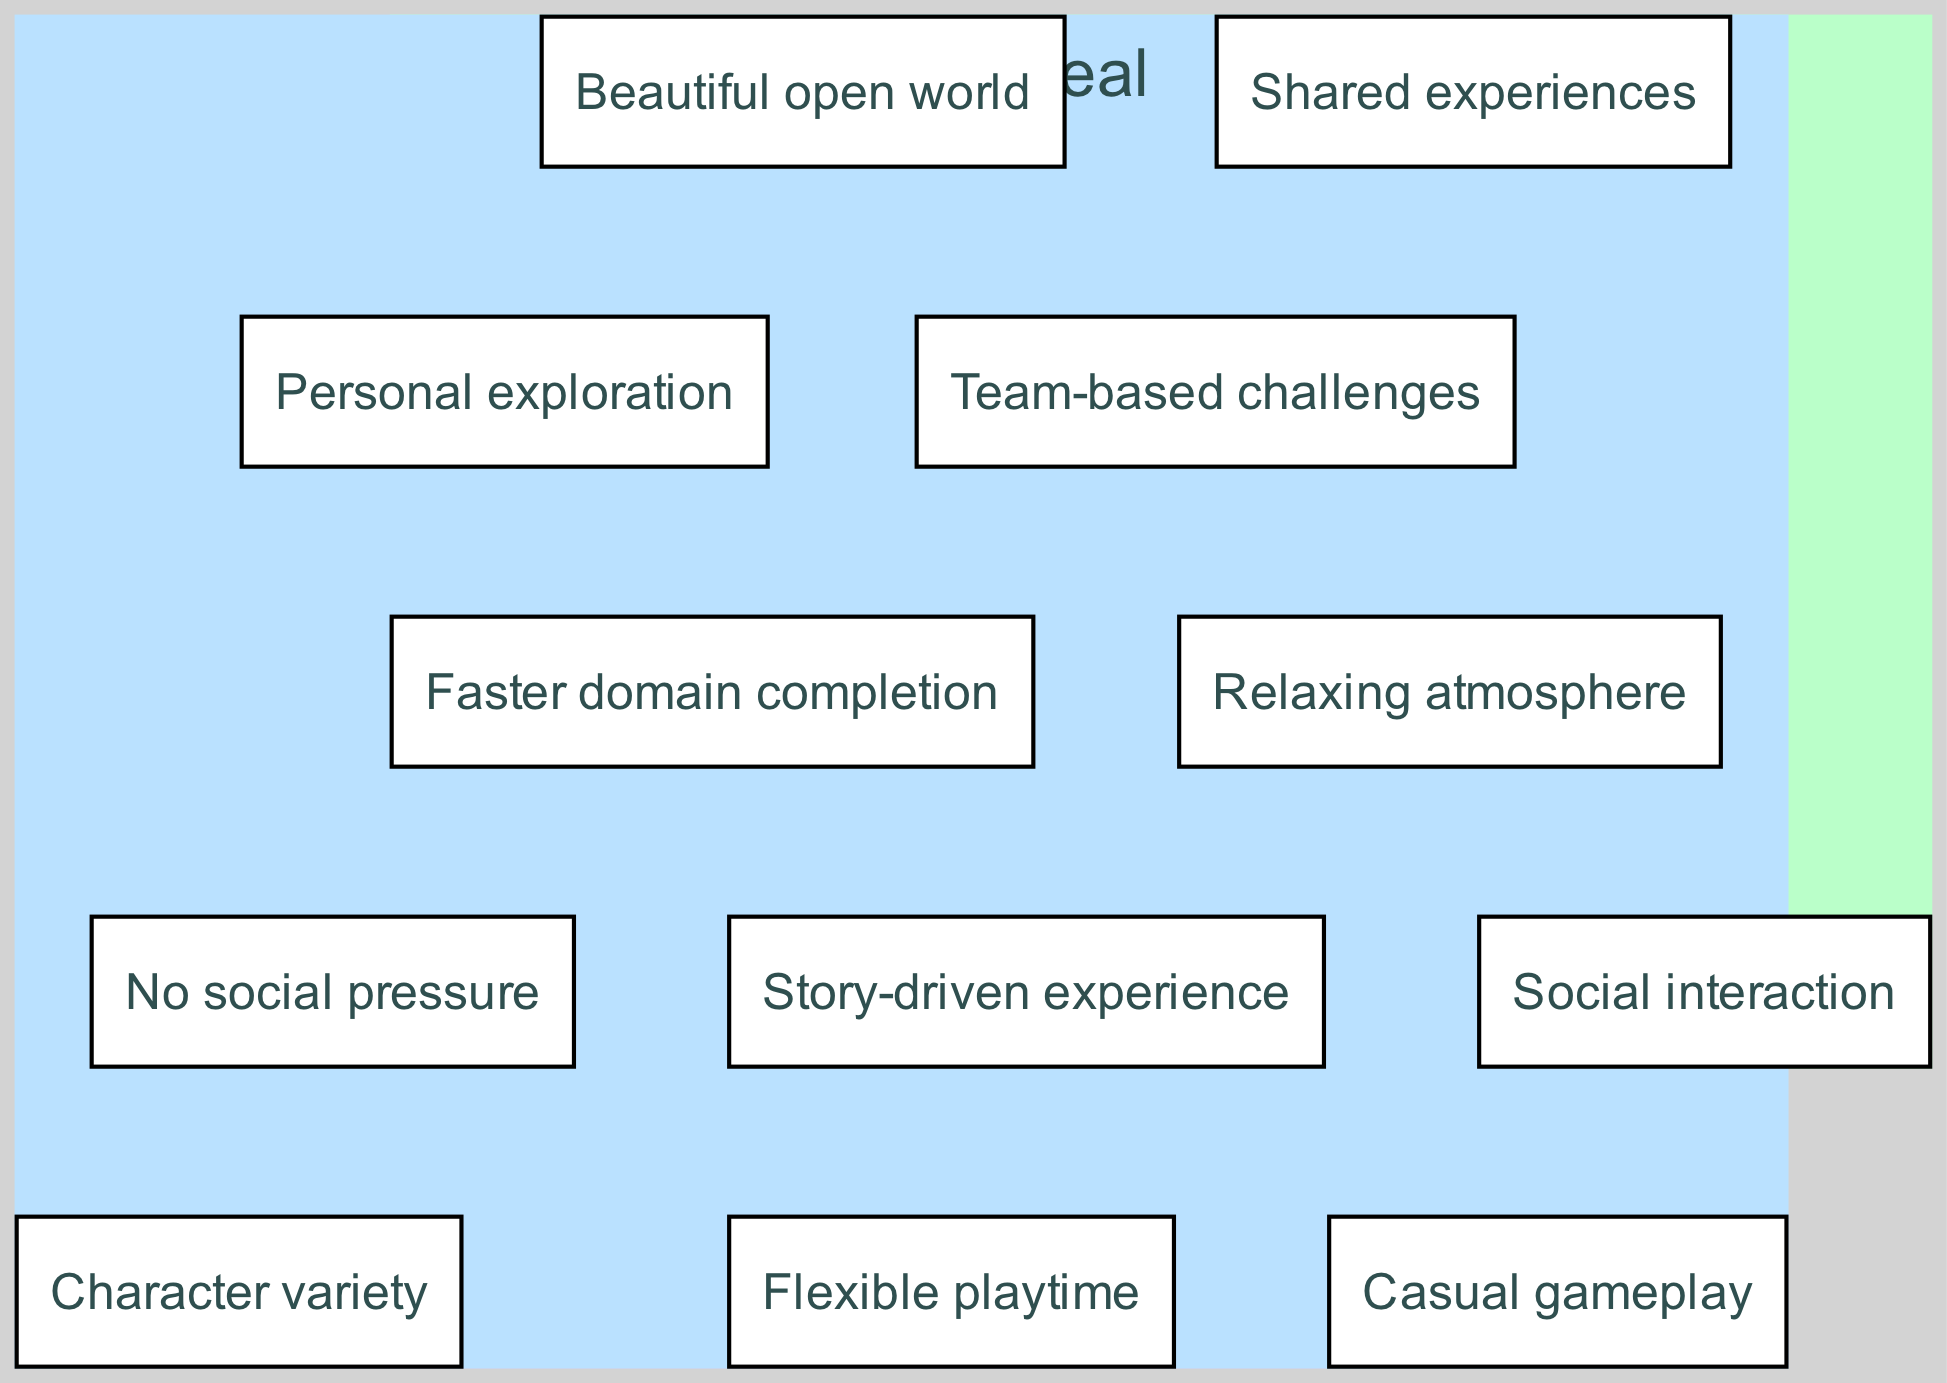What are the elements in the Single-Player Mode section? The Single-Player Mode section contains four elements: "Flexible playtime," "Story-driven experience," "Personal exploration," and "No social pressure." These elements can be directly observed listed under the Single-Player Mode node.
Answer: Flexible playtime, Story-driven experience, Personal exploration, No social pressure How many elements are listed in the Co-op Mode section? There are four elements listed under the Co-op Mode: "Social interaction," "Shared experiences," "Team-based challenges," and "Faster domain completion." By counting the items presented under the Co-op Mode node, we find there are four.
Answer: 4 What do the elements "Casual gameplay" and "Character variety" have in common? Both "Casual gameplay" and "Character variety" are listed in the Common Appeal intersection of the Venn diagram. This indicates they are appealing to both Single-Player and Co-op modes.
Answer: Both are in Common Appeal Which mode offers "Shared experiences"? The element "Shared experiences" is found exclusively in the Co-op Mode section, highlighting that this feature is particular to co-operative gameplay, as indicated by its placement under that node.
Answer: Co-op Mode What is the total number of unique elements in the diagram? The total number of unique elements is eight when you sum the four from Single-Player Mode, four from Co-op Mode, and add in the four from the intersection, without double-counting. Thus, 4 (Single-Player) + 4 (Co-op) = 8 unique elements.
Answer: 8 Which mode emphasizes a "Relaxing atmosphere"? The element "Relaxing atmosphere" is included in the Common Appeal intersection, implying that this characteristic is appreciated by players of both modes rather than being unique to one.
Answer: Common Appeal How many elements are there in the Common Appeal section? The Common Appeal section contains four elements: "Casual gameplay," "Character variety," "Beautiful open world," and "Relaxing atmosphere." By counting these listed elements, we confirm there are four in total.
Answer: 4 Which mode is preferable for "No social pressure"? The element "No social pressure" is found exclusively under the Single-Player Mode section. This indicates that playing in this mode allows for a more solitary and pressure-free experience, as specified by its placement.
Answer: Single-Player Mode 